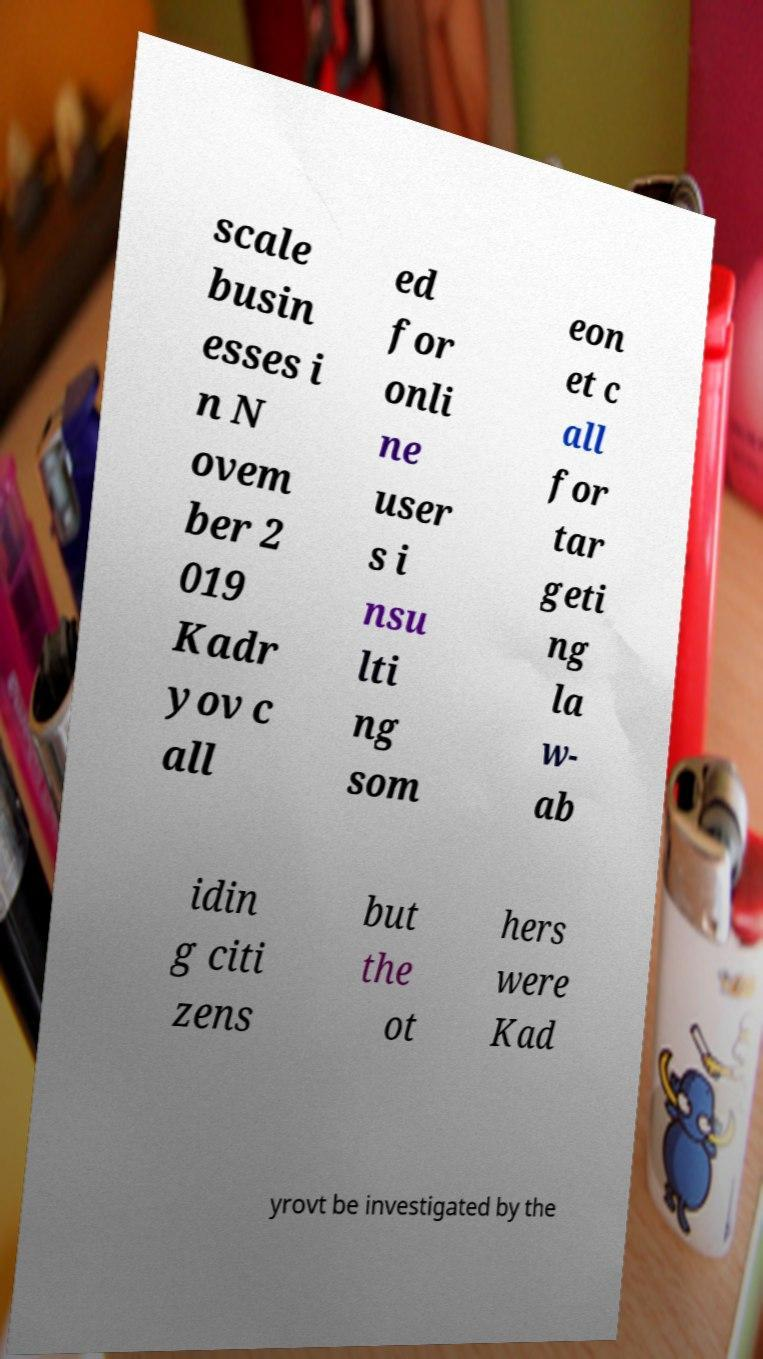There's text embedded in this image that I need extracted. Can you transcribe it verbatim? scale busin esses i n N ovem ber 2 019 Kadr yov c all ed for onli ne user s i nsu lti ng som eon et c all for tar geti ng la w- ab idin g citi zens but the ot hers were Kad yrovt be investigated by the 